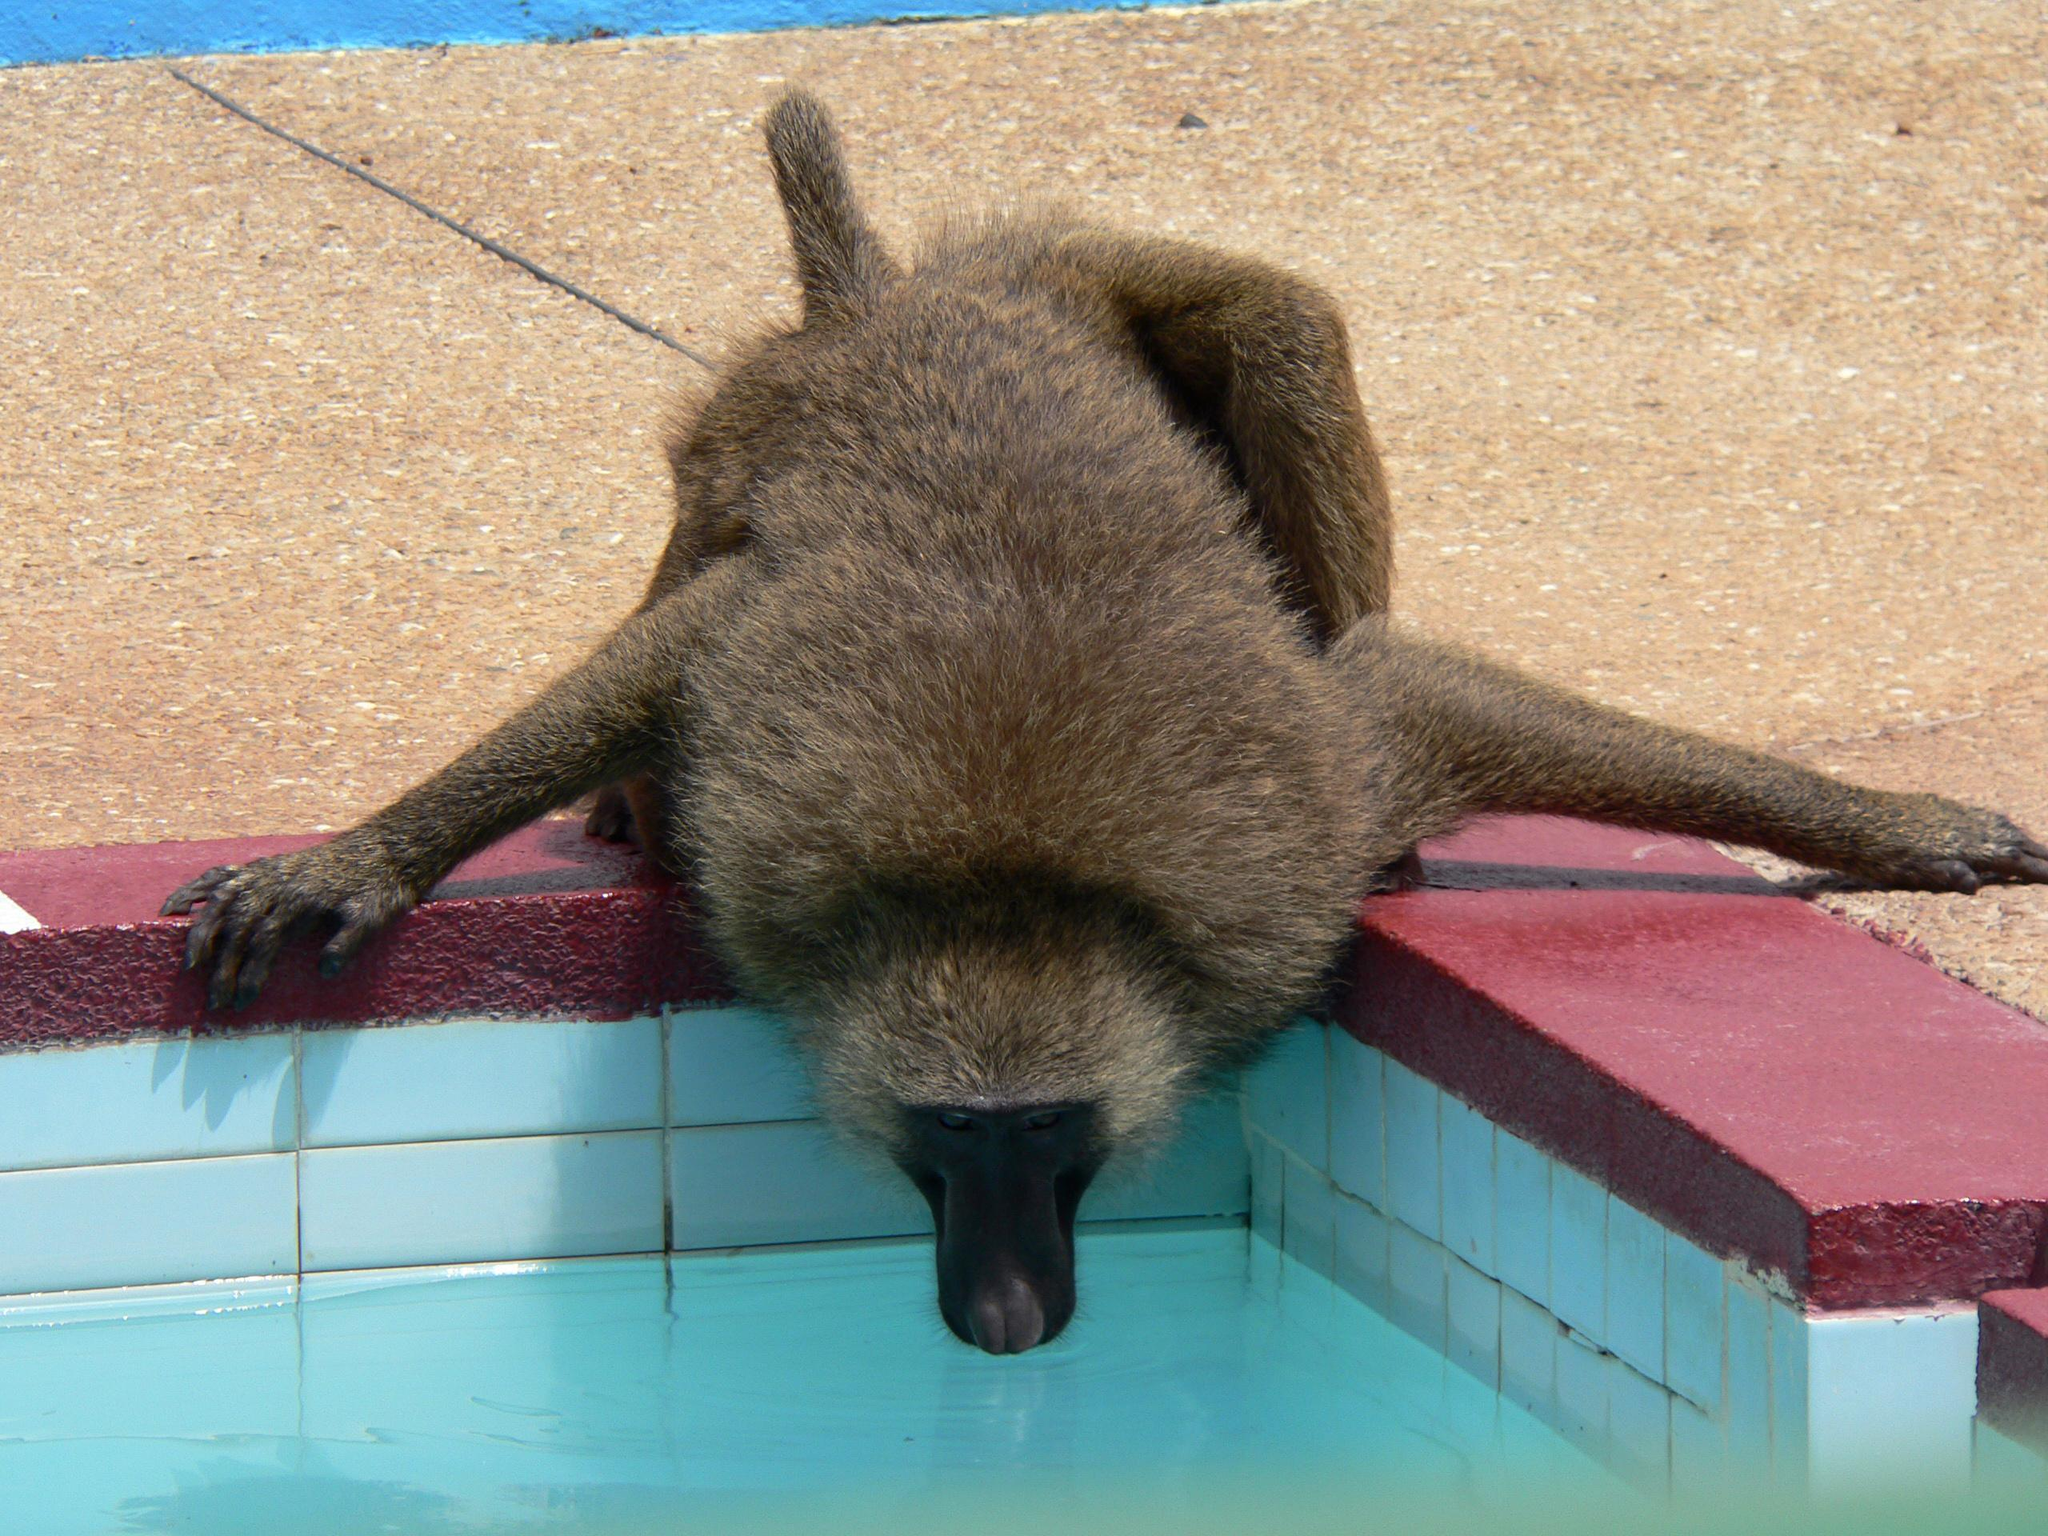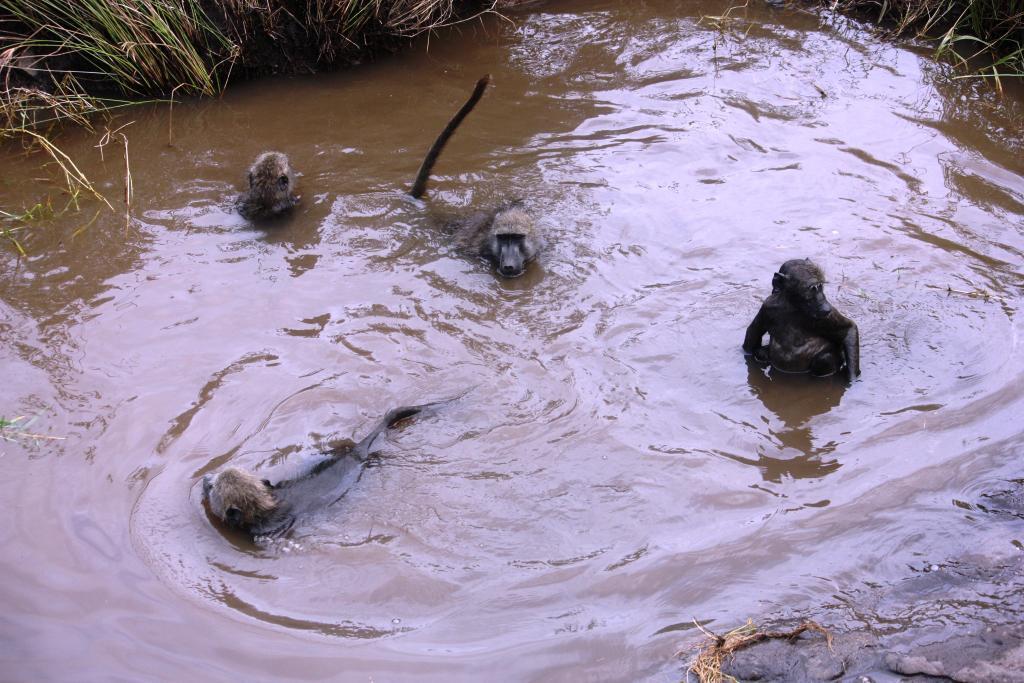The first image is the image on the left, the second image is the image on the right. For the images shown, is this caption "There is a man-made swimming area with a square corner." true? Answer yes or no. Yes. The first image is the image on the left, the second image is the image on the right. Considering the images on both sides, is "In one of the images, the pool is clearly man-made." valid? Answer yes or no. Yes. 